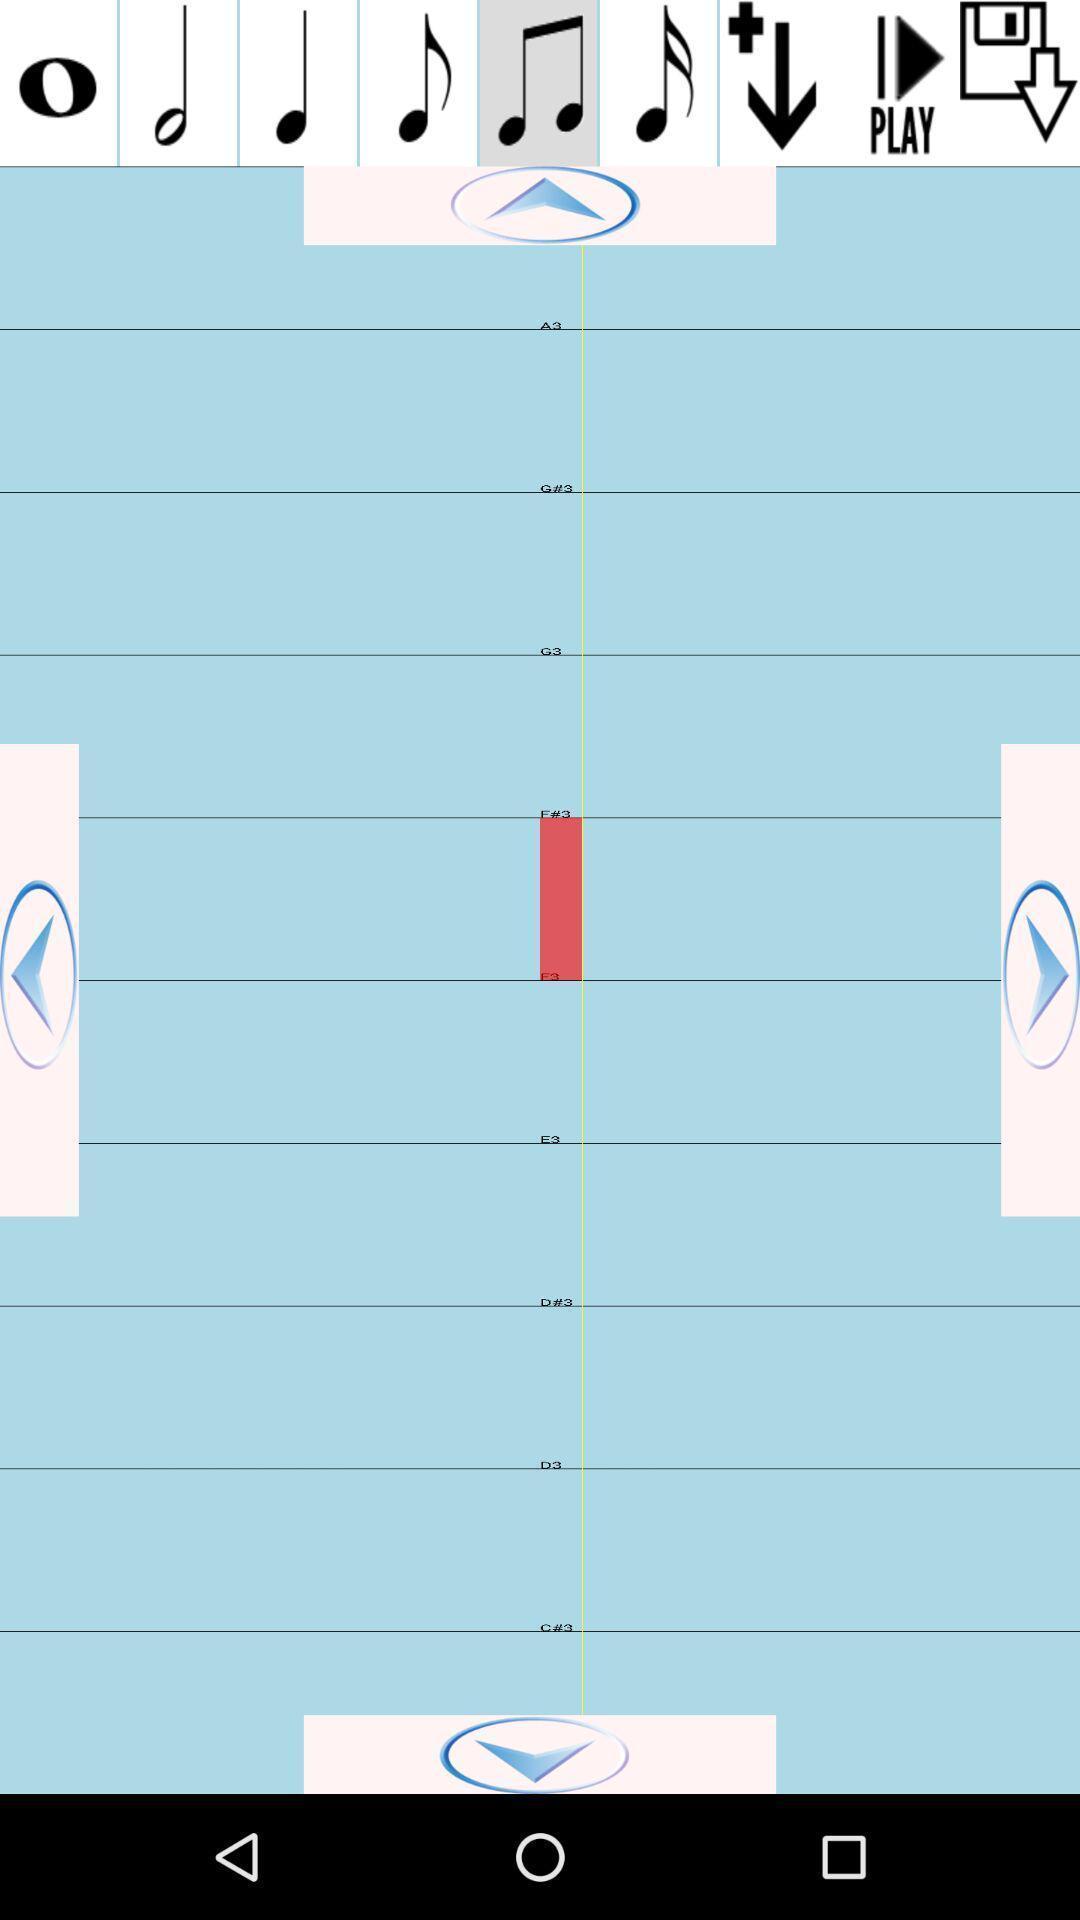What is the overall content of this screenshot? Screen displaying the page of a music app. 